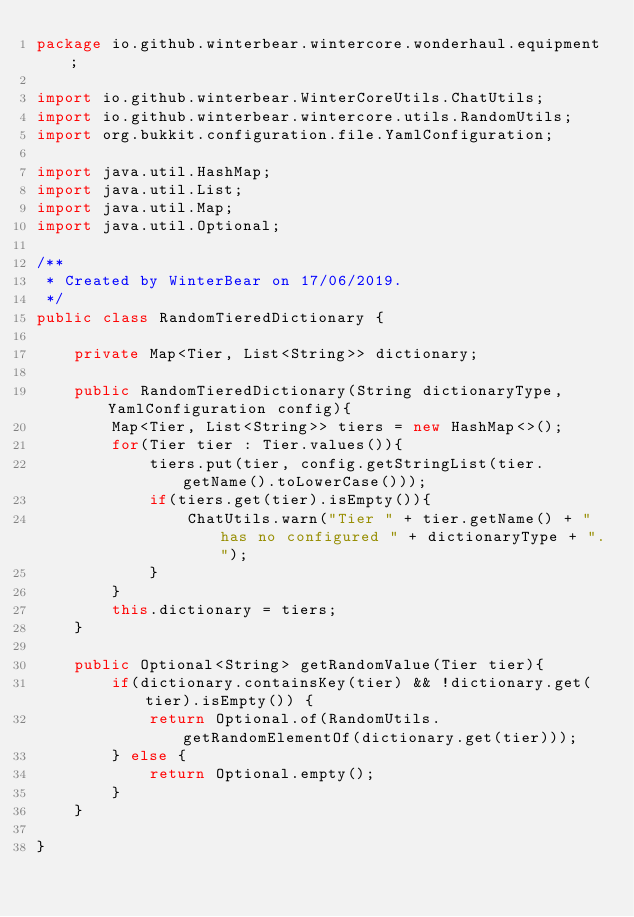Convert code to text. <code><loc_0><loc_0><loc_500><loc_500><_Java_>package io.github.winterbear.wintercore.wonderhaul.equipment;

import io.github.winterbear.WinterCoreUtils.ChatUtils;
import io.github.winterbear.wintercore.utils.RandomUtils;
import org.bukkit.configuration.file.YamlConfiguration;

import java.util.HashMap;
import java.util.List;
import java.util.Map;
import java.util.Optional;

/**
 * Created by WinterBear on 17/06/2019.
 */
public class RandomTieredDictionary {

    private Map<Tier, List<String>> dictionary;

    public RandomTieredDictionary(String dictionaryType, YamlConfiguration config){
        Map<Tier, List<String>> tiers = new HashMap<>();
        for(Tier tier : Tier.values()){
            tiers.put(tier, config.getStringList(tier.getName().toLowerCase()));
            if(tiers.get(tier).isEmpty()){
                ChatUtils.warn("Tier " + tier.getName() + " has no configured " + dictionaryType + ".");
            }
        }
        this.dictionary = tiers;
    }

    public Optional<String> getRandomValue(Tier tier){
        if(dictionary.containsKey(tier) && !dictionary.get(tier).isEmpty()) {
            return Optional.of(RandomUtils.getRandomElementOf(dictionary.get(tier)));
        } else {
            return Optional.empty();
        }
    }

}
</code> 